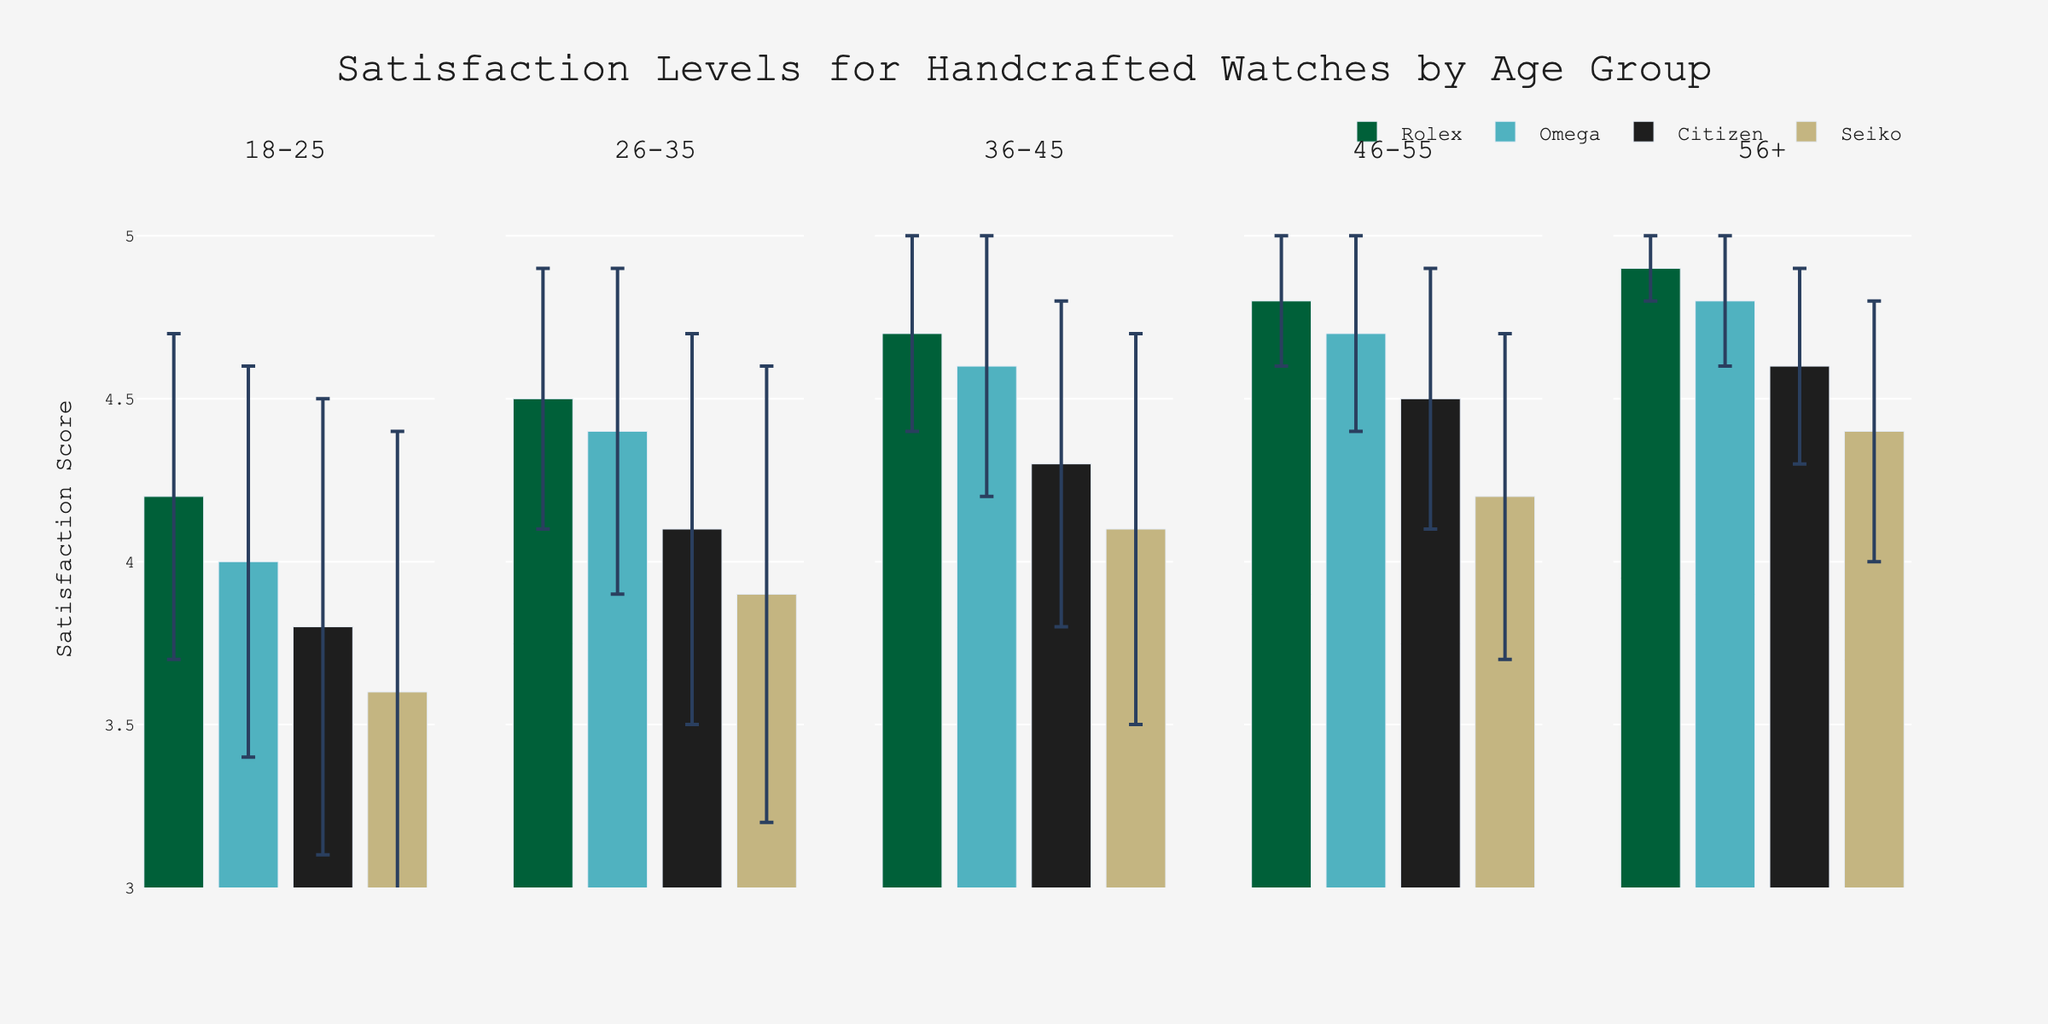What is the title of the figure? The title of the figure is located at the top and summarizes the entire plot's purpose.
Answer: Satisfaction Levels for Handcrafted Watches by Age Group Which age group has the highest mean satisfaction score for Rolex? By looking at each subplot for the different age groups, we can see which one has the highest bar for Rolex.
Answer: 56+ What is the satisfaction mean score for Citizen watches in the 36-45 age group? The satisfaction mean score for Citizen in the 36-45 age group can be found by locating the bar for Citizen in the 36-45 subplot.
Answer: 4.3 Which watch brand shows the highest variability in the 18-25 age group? Variability is represented by the error bars. The tallest error bar among the 18-25 age group indicates the highest variability.
Answer: Seiko Compare the mean satisfaction scores for Omega watches between the 26-35 and 46-55 age groups. Check the bar heights for Omega in the 26-35 and 46-55 subplots and compare their mean values.
Answer: 4.4 (26-35) and 4.7 (46-55) What is the average satisfaction mean score across all age groups for Seiko watches? Calculate the average by summing the mean satisfaction scores for Seiko in each age group and dividing by the number of age groups. (3.6 + 3.9 + 4.1 + 4.2 + 4.4) / 5 = 4.04
Answer: 4.04 Which age group has the smallest standard deviation for Rolex watches? The smallest standard deviation is shown by the shortest error bar. Look at the error bars for Rolex in all age groups and identify the smallest.
Answer: 56+ Is the satisfaction mean score for Omega watches higher in the 36-45 age group or the 56+ age group? Compare the bar heights for Omega in the 36-45 and 56+ subplots.
Answer: 56+ How much higher is the satisfaction mean score for Citizen watches in the 46-55 age group compared to the 18-25 age group? Subtract the satisfaction mean score of Citizen in the 18-25 age group from the score in the 46-55 age group. 4.5 - 3.8 = 0.7
Answer: 0.7 What can be inferred about the trend of satisfaction levels for Seiko watches as age increases? Observe the heights of the bars for Seiko in increasing age group subplots to see if there's a monotonic increase or another trend.
Answer: Increasing 